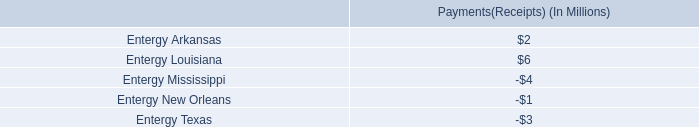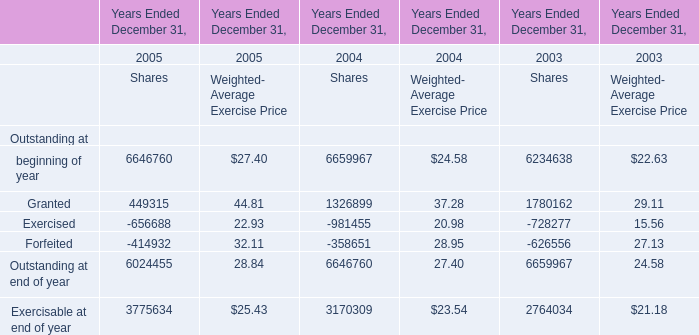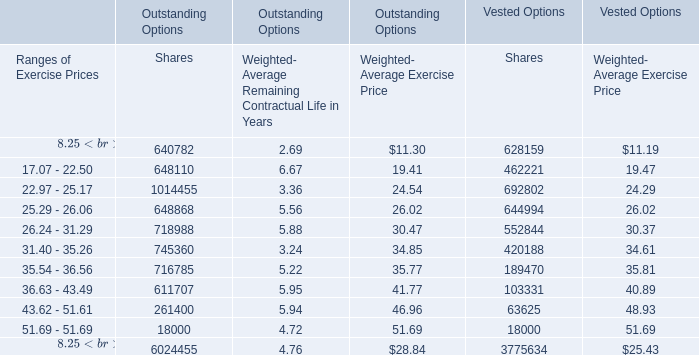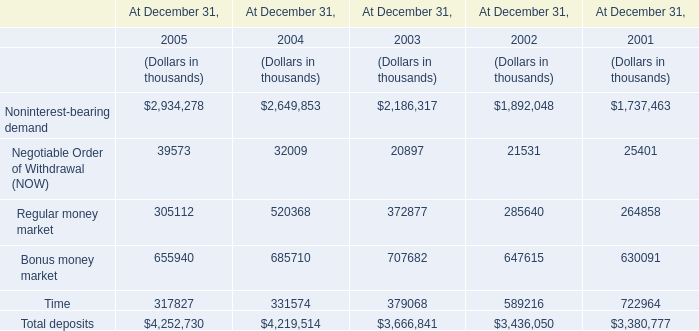What's the total amount of the Regular money market in the years where Granted for Outstanding at for Shares is greater than 0? (in thousand) 
Computations: ((305112 + 520368) + 372877)
Answer: 1198357.0. 